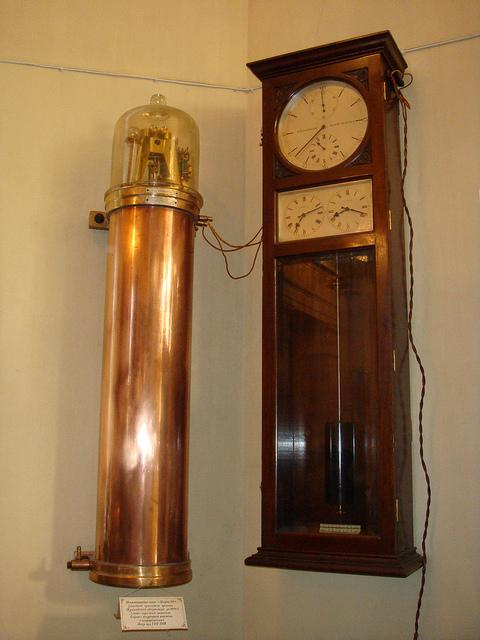What is connected to the long cylinder?

Choices:
A) egg
B) clock
C) gargoyle
D) vacuum clock 